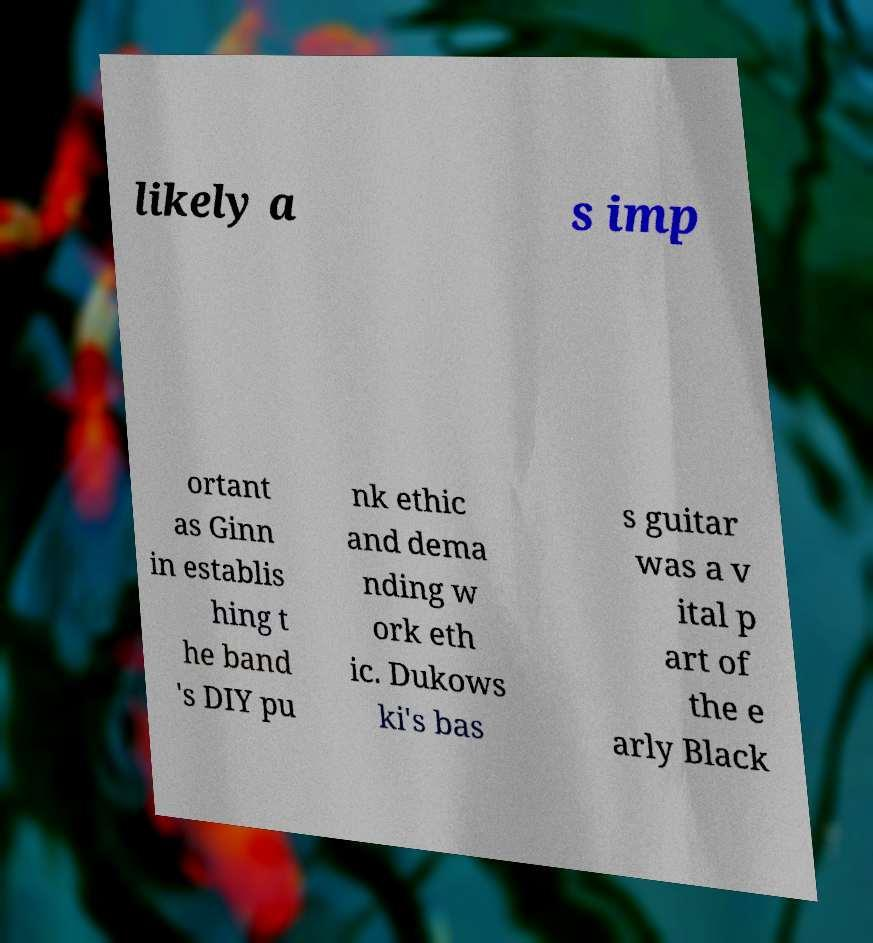Can you read and provide the text displayed in the image?This photo seems to have some interesting text. Can you extract and type it out for me? likely a s imp ortant as Ginn in establis hing t he band 's DIY pu nk ethic and dema nding w ork eth ic. Dukows ki's bas s guitar was a v ital p art of the e arly Black 